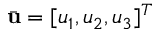<formula> <loc_0><loc_0><loc_500><loc_500>\bar { u } = [ u _ { 1 } , u _ { 2 } , u _ { 3 } ] ^ { T }</formula> 